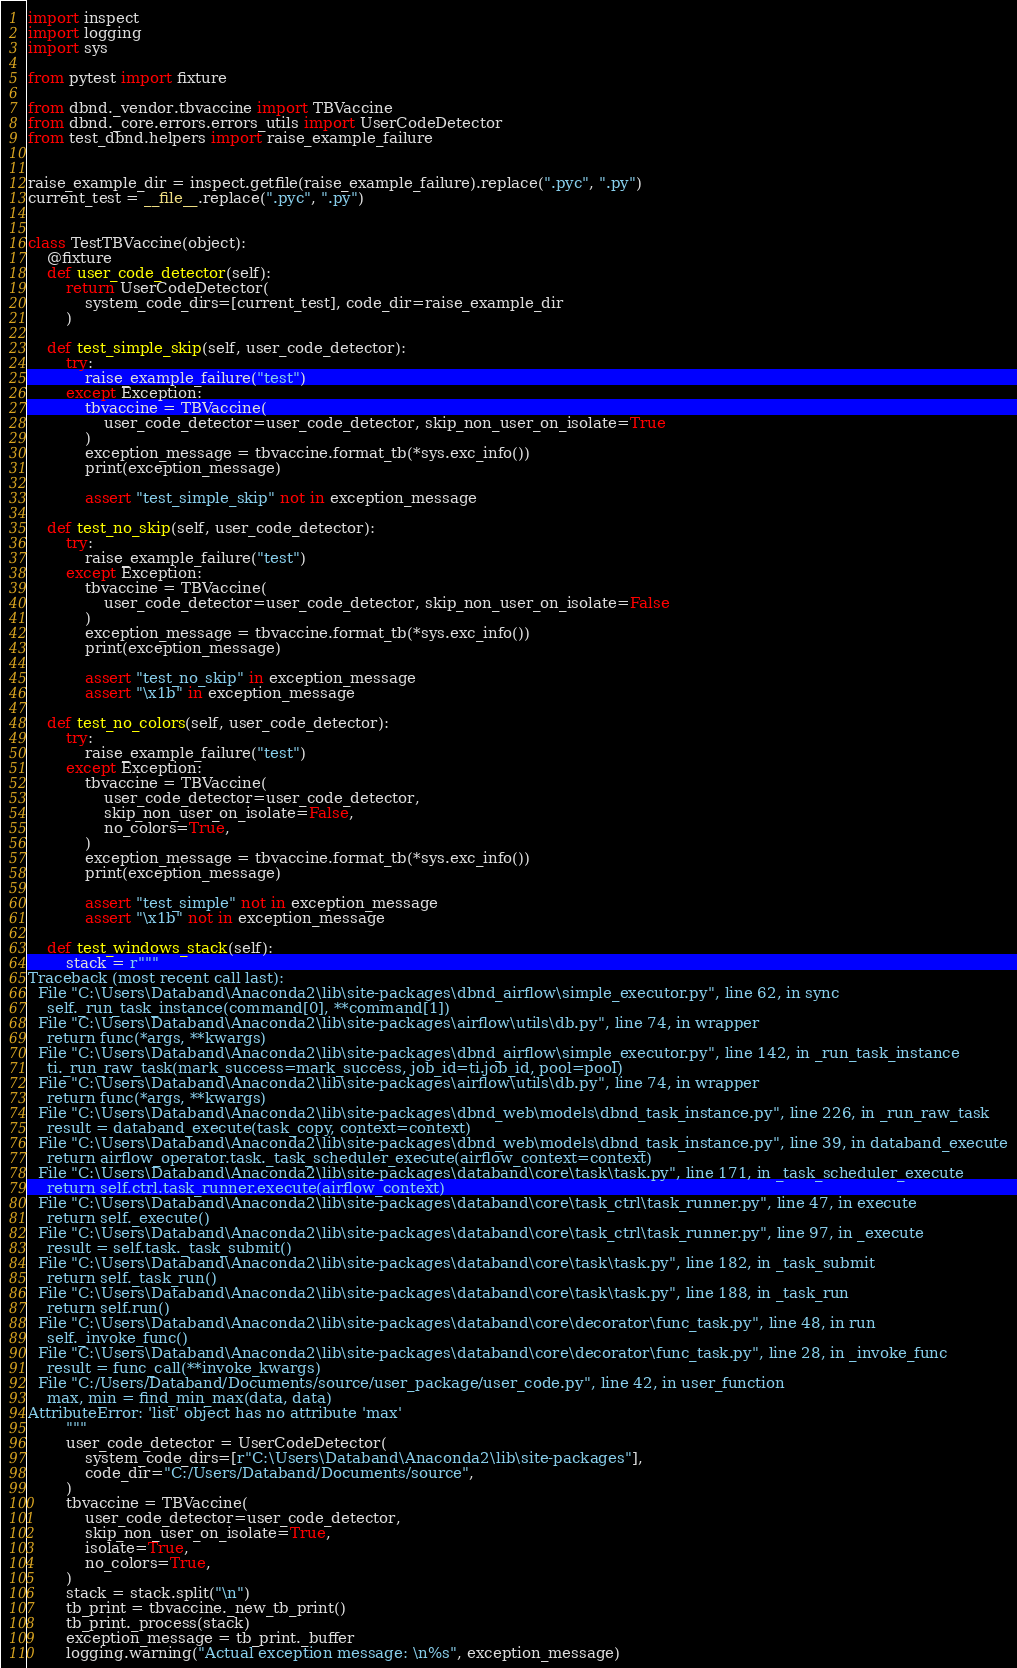<code> <loc_0><loc_0><loc_500><loc_500><_Python_>import inspect
import logging
import sys

from pytest import fixture

from dbnd._vendor.tbvaccine import TBVaccine
from dbnd._core.errors.errors_utils import UserCodeDetector
from test_dbnd.helpers import raise_example_failure


raise_example_dir = inspect.getfile(raise_example_failure).replace(".pyc", ".py")
current_test = __file__.replace(".pyc", ".py")


class TestTBVaccine(object):
    @fixture
    def user_code_detector(self):
        return UserCodeDetector(
            system_code_dirs=[current_test], code_dir=raise_example_dir
        )

    def test_simple_skip(self, user_code_detector):
        try:
            raise_example_failure("test")
        except Exception:
            tbvaccine = TBVaccine(
                user_code_detector=user_code_detector, skip_non_user_on_isolate=True
            )
            exception_message = tbvaccine.format_tb(*sys.exc_info())
            print(exception_message)

            assert "test_simple_skip" not in exception_message

    def test_no_skip(self, user_code_detector):
        try:
            raise_example_failure("test")
        except Exception:
            tbvaccine = TBVaccine(
                user_code_detector=user_code_detector, skip_non_user_on_isolate=False
            )
            exception_message = tbvaccine.format_tb(*sys.exc_info())
            print(exception_message)

            assert "test_no_skip" in exception_message
            assert "\x1b" in exception_message

    def test_no_colors(self, user_code_detector):
        try:
            raise_example_failure("test")
        except Exception:
            tbvaccine = TBVaccine(
                user_code_detector=user_code_detector,
                skip_non_user_on_isolate=False,
                no_colors=True,
            )
            exception_message = tbvaccine.format_tb(*sys.exc_info())
            print(exception_message)

            assert "test_simple" not in exception_message
            assert "\x1b" not in exception_message

    def test_windows_stack(self):
        stack = r"""
Traceback (most recent call last):
  File "C:\Users\Databand\Anaconda2\lib\site-packages\dbnd_airflow\simple_executor.py", line 62, in sync
    self._run_task_instance(command[0], **command[1])
  File "C:\Users\Databand\Anaconda2\lib\site-packages\airflow\utils\db.py", line 74, in wrapper
    return func(*args, **kwargs)
  File "C:\Users\Databand\Anaconda2\lib\site-packages\dbnd_airflow\simple_executor.py", line 142, in _run_task_instance
    ti._run_raw_task(mark_success=mark_success, job_id=ti.job_id, pool=pool)
  File "C:\Users\Databand\Anaconda2\lib\site-packages\airflow\utils\db.py", line 74, in wrapper
    return func(*args, **kwargs)
  File "C:\Users\Databand\Anaconda2\lib\site-packages\dbnd_web\models\dbnd_task_instance.py", line 226, in _run_raw_task
    result = databand_execute(task_copy, context=context)
  File "C:\Users\Databand\Anaconda2\lib\site-packages\dbnd_web\models\dbnd_task_instance.py", line 39, in databand_execute
    return airflow_operator.task._task_scheduler_execute(airflow_context=context)
  File "C:\Users\Databand\Anaconda2\lib\site-packages\databand\core\task\task.py", line 171, in _task_scheduler_execute
    return self.ctrl.task_runner.execute(airflow_context)
  File "C:\Users\Databand\Anaconda2\lib\site-packages\databand\core\task_ctrl\task_runner.py", line 47, in execute
    return self._execute()
  File "C:\Users\Databand\Anaconda2\lib\site-packages\databand\core\task_ctrl\task_runner.py", line 97, in _execute
    result = self.task._task_submit()
  File "C:\Users\Databand\Anaconda2\lib\site-packages\databand\core\task\task.py", line 182, in _task_submit
    return self._task_run()
  File "C:\Users\Databand\Anaconda2\lib\site-packages\databand\core\task\task.py", line 188, in _task_run
    return self.run()
  File "C:\Users\Databand\Anaconda2\lib\site-packages\databand\core\decorator\func_task.py", line 48, in run
    self._invoke_func()
  File "C:\Users\Databand\Anaconda2\lib\site-packages\databand\core\decorator\func_task.py", line 28, in _invoke_func
    result = func_call(**invoke_kwargs)
  File "C:/Users/Databand/Documents/source/user_package/user_code.py", line 42, in user_function
    max, min = find_min_max(data, data)
AttributeError: 'list' object has no attribute 'max'
        """
        user_code_detector = UserCodeDetector(
            system_code_dirs=[r"C:\Users\Databand\Anaconda2\lib\site-packages"],
            code_dir="C:/Users/Databand/Documents/source",
        )
        tbvaccine = TBVaccine(
            user_code_detector=user_code_detector,
            skip_non_user_on_isolate=True,
            isolate=True,
            no_colors=True,
        )
        stack = stack.split("\n")
        tb_print = tbvaccine._new_tb_print()
        tb_print._process(stack)
        exception_message = tb_print._buffer
        logging.warning("Actual exception message: \n%s", exception_message)
</code> 